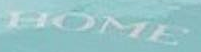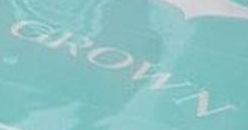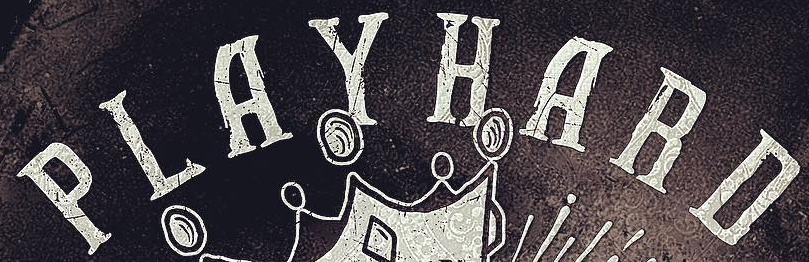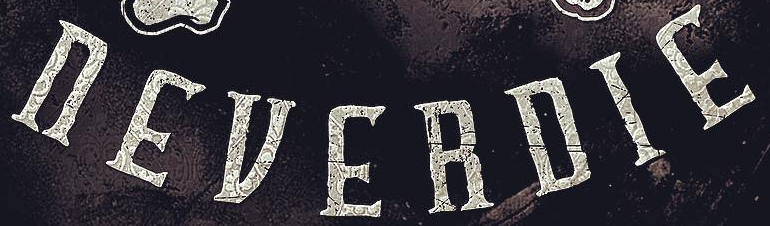Transcribe the words shown in these images in order, separated by a semicolon. HOME; GROWN; PLAYHARD; nEVERDIE 